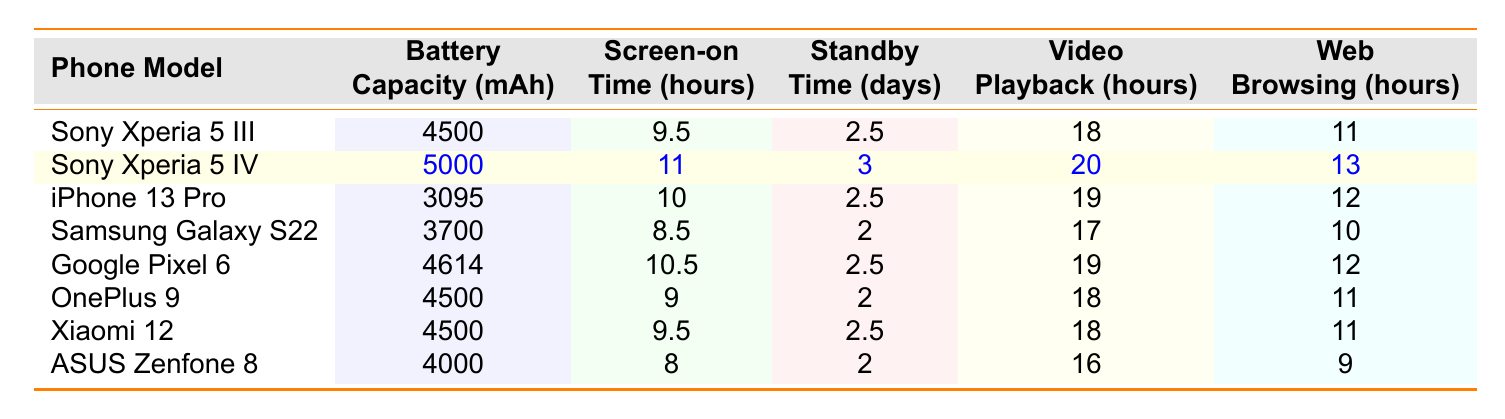What is the battery capacity of the Sony Xperia 5 IV? The table states that the battery capacity of the Sony Xperia 5 IV is 5000 mAh.
Answer: 5000 mAh Which phone has the longest screen-on time? By comparing the screen-on time values, the Sony Xperia 5 IV has the longest screen-on time at 11 hours.
Answer: Sony Xperia 5 IV True or False: The Samsung Galaxy S22 has a longer standby time than the Google Pixel 6. The standby time for the Samsung Galaxy S22 is 2 days, while the Google Pixel 6 has 2.5 days; therefore, the Samsung Galaxy S22 does not have a longer standby time.
Answer: False What is the difference in video playback time between the Sony Xperia 5 IV and the iPhone 13 Pro? The video playback time for the Sony Xperia 5 IV is 20 hours, and for the iPhone 13 Pro, it is 19 hours. The difference is 20 - 19 = 1 hour.
Answer: 1 hour Which phone has the highest web browsing time, and what is it? The Sony Xperia 5 IV has the highest web browsing time of 13 hours. Other phones have less web browsing time.
Answer: Sony Xperia 5 IV, 13 hours What is the average battery capacity of the Sony Xperia 5 series models? The battery capacity of the Sony Xperia 5 III is 4500 mAh and the 5 IV is 5000 mAh. The average is (4500 + 5000) / 2 = 4750 mAh.
Answer: 4750 mAh Which competitor has a battery capacity closest to the Sony Xperia 5 III? The competitors with battery capacities are: iPhone 13 Pro (3095 mAh), Samsung Galaxy S22 (3700 mAh), Google Pixel 6 (4614 mAh), OnePlus 9 (4500 mAh), Xiaomi 12 (4500 mAh), ASUS Zenfone 8 (4000 mAh). OnePlus 9 and Xiaomi 12 have the same capacity of 4500 mAh, which is closest to the 5 III.
Answer: OnePlus 9 or Xiaomi 12 If you combined the screen-on time of the Sony Xperia 5 III and iPhone 13 Pro, what would that be? The screen-on time for the Sony Xperia 5 III is 9.5 hours and for the iPhone 13 Pro is 10 hours. Combined, that is 9.5 + 10 = 19.5 hours.
Answer: 19.5 hours Which phone offers the best video playback time and how much is it? The Sony Xperia 5 IV offers the best video playback time, at 20 hours, compared to others listed in the table.
Answer: Sony Xperia 5 IV, 20 hours Is the battery capacity of the Google Pixel 6 higher than that of the Samsung Galaxy S22? The battery capacity of the Google Pixel 6 is 4614 mAh, while the Samsung Galaxy S22 has 3700 mAh. Therefore, the Google Pixel 6 has a higher capacity.
Answer: Yes 